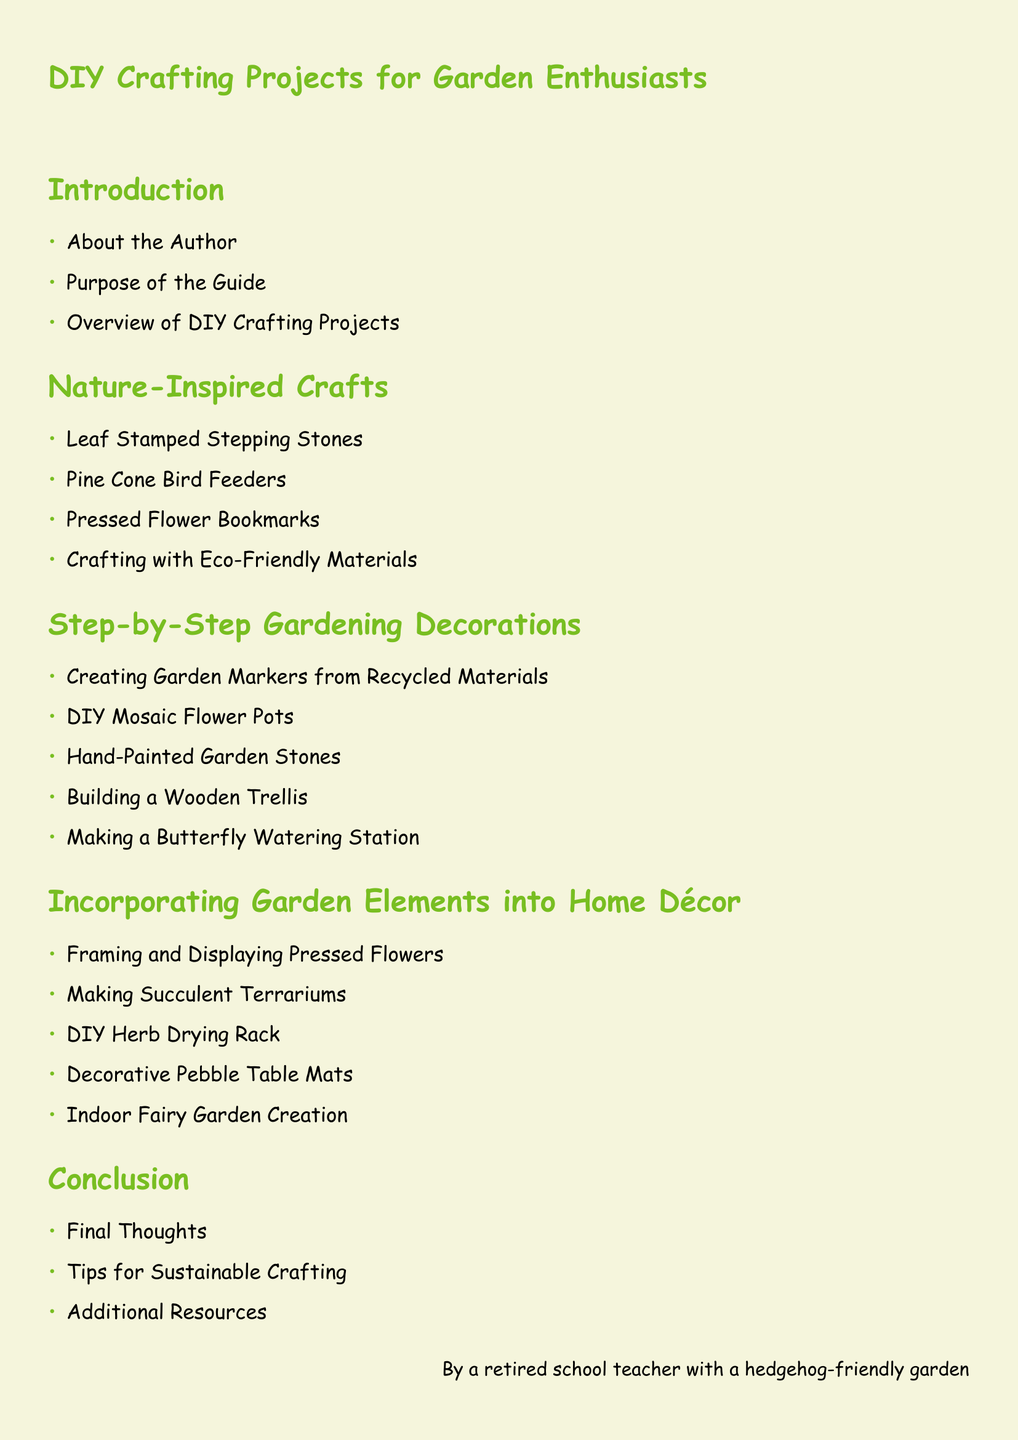What section introduces the author? The introduction section includes "About the Author."
Answer: About the Author How many nature-inspired craft projects are listed? There are four projects mentioned in the nature-inspired crafts section.
Answer: 4 What is the title of the third subsection in gardening decorations? The third project listed is "Hand-Painted Garden Stones."
Answer: Hand-Painted Garden Stones Which section contains information on "Making Succulent Terrariums"? "Incorporating Garden Elements into Home Décor" section includes this project.
Answer: Incorporating Garden Elements into Home Décor What is the last topic covered in the conclusion? The last item listed in the conclusion is "Additional Resources."
Answer: Additional Resources Name one craft that uses eco-friendly materials. The nature-inspired crafts section includes "Crafting with Eco-Friendly Materials."
Answer: Crafting with Eco-Friendly Materials How many gardening decoration projects are there? There are five gardening decoration projects listed in that section.
Answer: 5 Which crafting project is associated with creating garden markers? "Creating Garden Markers from Recycled Materials" is associated with this task.
Answer: Creating Garden Markers from Recycled Materials 